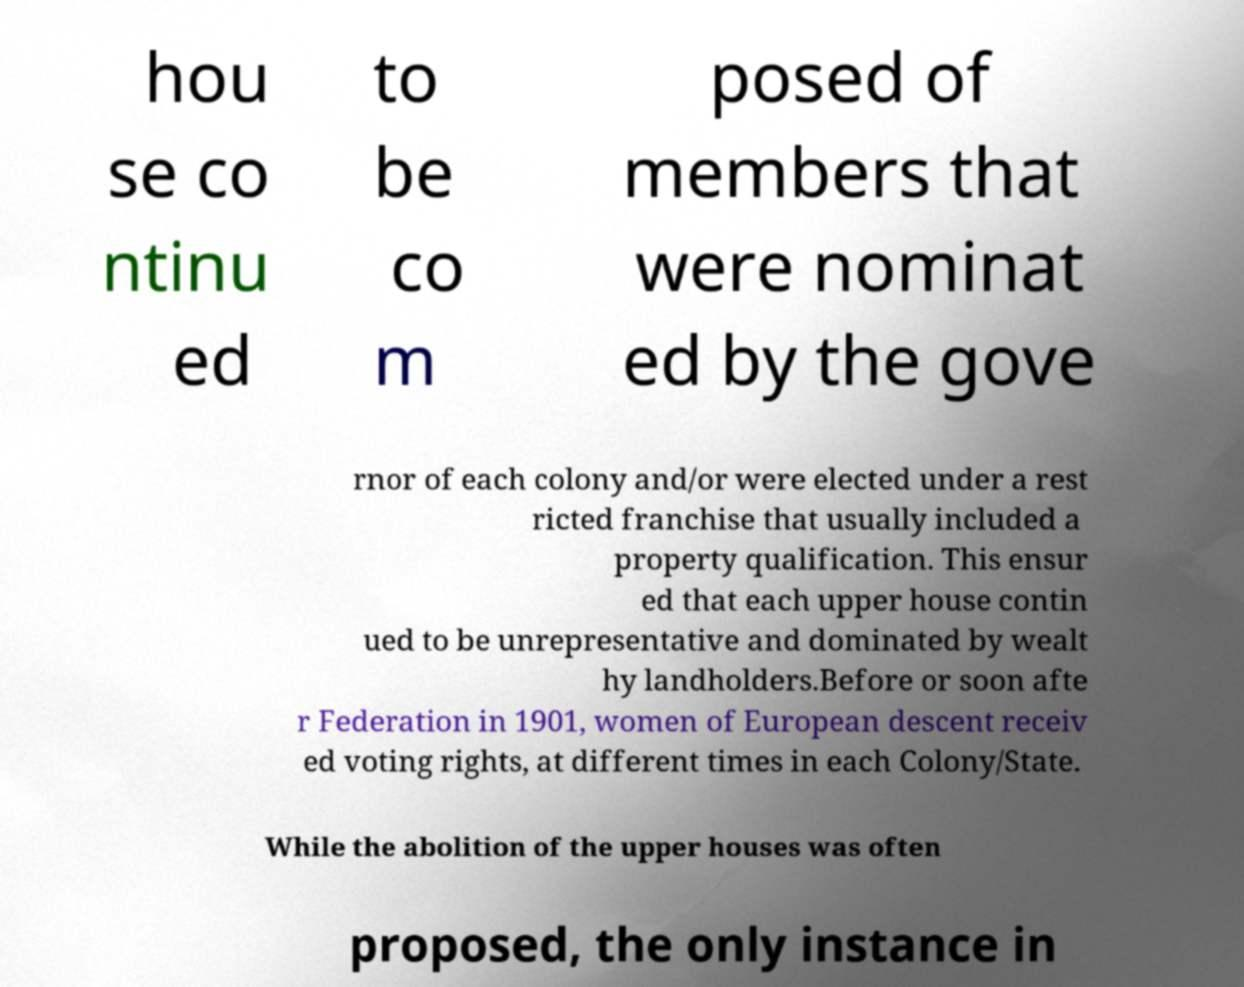Could you assist in decoding the text presented in this image and type it out clearly? hou se co ntinu ed to be co m posed of members that were nominat ed by the gove rnor of each colony and/or were elected under a rest ricted franchise that usually included a property qualification. This ensur ed that each upper house contin ued to be unrepresentative and dominated by wealt hy landholders.Before or soon afte r Federation in 1901, women of European descent receiv ed voting rights, at different times in each Colony/State. While the abolition of the upper houses was often proposed, the only instance in 